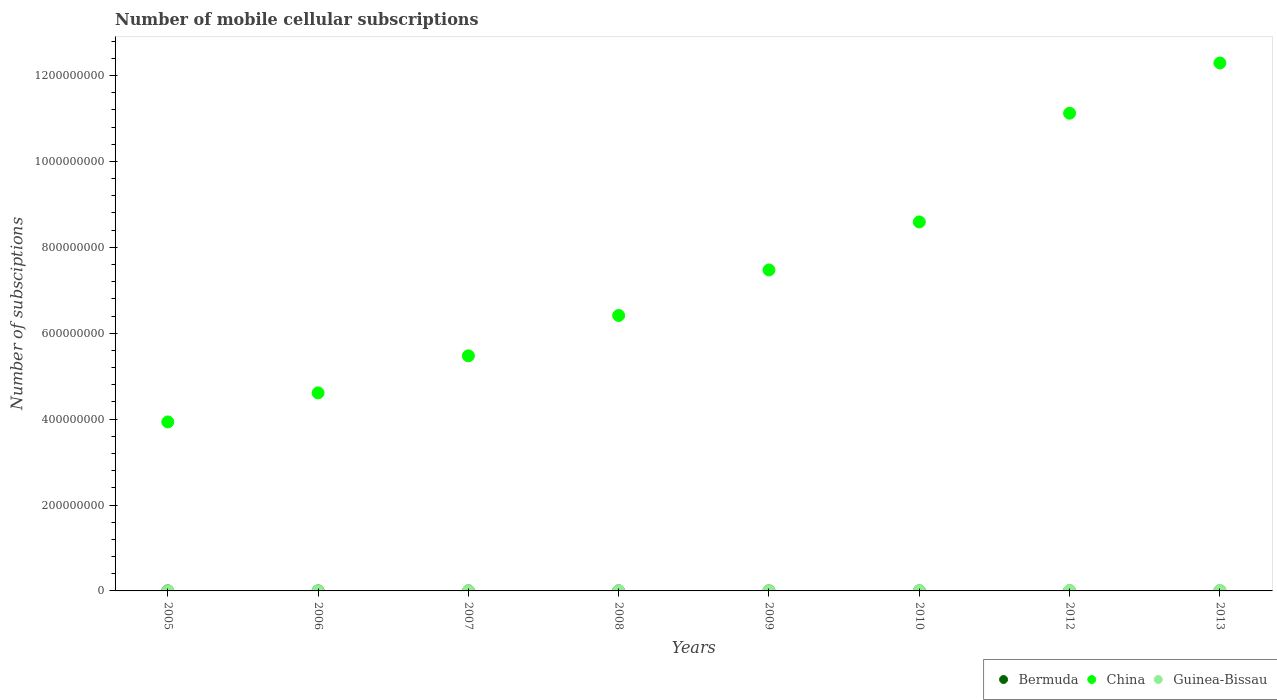What is the number of mobile cellular subscriptions in Bermuda in 2012?
Keep it short and to the point. 9.10e+04. Across all years, what is the maximum number of mobile cellular subscriptions in China?
Offer a very short reply. 1.23e+09. Across all years, what is the minimum number of mobile cellular subscriptions in Guinea-Bissau?
Your response must be concise. 9.88e+04. In which year was the number of mobile cellular subscriptions in China minimum?
Your response must be concise. 2005. What is the total number of mobile cellular subscriptions in China in the graph?
Ensure brevity in your answer.  5.99e+09. What is the difference between the number of mobile cellular subscriptions in Guinea-Bissau in 2006 and that in 2013?
Offer a terse response. -7.83e+05. What is the difference between the number of mobile cellular subscriptions in China in 2010 and the number of mobile cellular subscriptions in Guinea-Bissau in 2012?
Give a very brief answer. 8.58e+08. What is the average number of mobile cellular subscriptions in China per year?
Your answer should be very brief. 7.49e+08. In the year 2010, what is the difference between the number of mobile cellular subscriptions in Guinea-Bissau and number of mobile cellular subscriptions in China?
Offer a very short reply. -8.58e+08. In how many years, is the number of mobile cellular subscriptions in Guinea-Bissau greater than 720000000?
Your response must be concise. 0. What is the ratio of the number of mobile cellular subscriptions in Bermuda in 2005 to that in 2010?
Provide a succinct answer. 0.6. What is the difference between the highest and the second highest number of mobile cellular subscriptions in Bermuda?
Your answer should be compact. 3300. What is the difference between the highest and the lowest number of mobile cellular subscriptions in Guinea-Bissau?
Provide a succinct answer. 9.50e+05. Is the sum of the number of mobile cellular subscriptions in Bermuda in 2005 and 2006 greater than the maximum number of mobile cellular subscriptions in Guinea-Bissau across all years?
Make the answer very short. No. Does the number of mobile cellular subscriptions in Guinea-Bissau monotonically increase over the years?
Keep it short and to the point. No. What is the difference between two consecutive major ticks on the Y-axis?
Make the answer very short. 2.00e+08. Does the graph contain any zero values?
Your answer should be very brief. No. What is the title of the graph?
Your response must be concise. Number of mobile cellular subscriptions. What is the label or title of the X-axis?
Offer a terse response. Years. What is the label or title of the Y-axis?
Provide a succinct answer. Number of subsciptions. What is the Number of subsciptions in Bermuda in 2005?
Offer a terse response. 5.27e+04. What is the Number of subsciptions in China in 2005?
Provide a short and direct response. 3.93e+08. What is the Number of subsciptions in Guinea-Bissau in 2005?
Offer a very short reply. 9.88e+04. What is the Number of subsciptions in Bermuda in 2006?
Give a very brief answer. 6.01e+04. What is the Number of subsciptions in China in 2006?
Offer a terse response. 4.61e+08. What is the Number of subsciptions in Guinea-Bissau in 2006?
Your answer should be compact. 1.57e+05. What is the Number of subsciptions in Bermuda in 2007?
Provide a succinct answer. 6.90e+04. What is the Number of subsciptions of China in 2007?
Offer a terse response. 5.47e+08. What is the Number of subsciptions in Guinea-Bissau in 2007?
Offer a terse response. 2.96e+05. What is the Number of subsciptions of Bermuda in 2008?
Your response must be concise. 7.90e+04. What is the Number of subsciptions of China in 2008?
Ensure brevity in your answer.  6.41e+08. What is the Number of subsciptions of Guinea-Bissau in 2008?
Provide a succinct answer. 5.00e+05. What is the Number of subsciptions in Bermuda in 2009?
Keep it short and to the point. 8.50e+04. What is the Number of subsciptions of China in 2009?
Your response must be concise. 7.47e+08. What is the Number of subsciptions of Guinea-Bissau in 2009?
Ensure brevity in your answer.  5.60e+05. What is the Number of subsciptions of Bermuda in 2010?
Your answer should be compact. 8.82e+04. What is the Number of subsciptions of China in 2010?
Provide a succinct answer. 8.59e+08. What is the Number of subsciptions in Guinea-Bissau in 2010?
Ensure brevity in your answer.  6.77e+05. What is the Number of subsciptions of Bermuda in 2012?
Provide a succinct answer. 9.10e+04. What is the Number of subsciptions in China in 2012?
Provide a short and direct response. 1.11e+09. What is the Number of subsciptions in Guinea-Bissau in 2012?
Your answer should be very brief. 1.05e+06. What is the Number of subsciptions in Bermuda in 2013?
Make the answer very short. 9.43e+04. What is the Number of subsciptions of China in 2013?
Ensure brevity in your answer.  1.23e+09. What is the Number of subsciptions in Guinea-Bissau in 2013?
Give a very brief answer. 9.40e+05. Across all years, what is the maximum Number of subsciptions in Bermuda?
Offer a very short reply. 9.43e+04. Across all years, what is the maximum Number of subsciptions of China?
Your answer should be very brief. 1.23e+09. Across all years, what is the maximum Number of subsciptions of Guinea-Bissau?
Provide a short and direct response. 1.05e+06. Across all years, what is the minimum Number of subsciptions of Bermuda?
Provide a succinct answer. 5.27e+04. Across all years, what is the minimum Number of subsciptions in China?
Your response must be concise. 3.93e+08. Across all years, what is the minimum Number of subsciptions of Guinea-Bissau?
Your answer should be compact. 9.88e+04. What is the total Number of subsciptions of Bermuda in the graph?
Your answer should be compact. 6.19e+05. What is the total Number of subsciptions in China in the graph?
Ensure brevity in your answer.  5.99e+09. What is the total Number of subsciptions of Guinea-Bissau in the graph?
Offer a very short reply. 4.28e+06. What is the difference between the Number of subsciptions of Bermuda in 2005 and that in 2006?
Offer a terse response. -7380. What is the difference between the Number of subsciptions of China in 2005 and that in 2006?
Make the answer very short. -6.77e+07. What is the difference between the Number of subsciptions of Guinea-Bissau in 2005 and that in 2006?
Offer a terse response. -5.85e+04. What is the difference between the Number of subsciptions in Bermuda in 2005 and that in 2007?
Make the answer very short. -1.63e+04. What is the difference between the Number of subsciptions in China in 2005 and that in 2007?
Keep it short and to the point. -1.54e+08. What is the difference between the Number of subsciptions of Guinea-Bissau in 2005 and that in 2007?
Keep it short and to the point. -1.97e+05. What is the difference between the Number of subsciptions of Bermuda in 2005 and that in 2008?
Your answer should be very brief. -2.63e+04. What is the difference between the Number of subsciptions of China in 2005 and that in 2008?
Ensure brevity in your answer.  -2.48e+08. What is the difference between the Number of subsciptions of Guinea-Bissau in 2005 and that in 2008?
Provide a succinct answer. -4.01e+05. What is the difference between the Number of subsciptions in Bermuda in 2005 and that in 2009?
Your response must be concise. -3.23e+04. What is the difference between the Number of subsciptions in China in 2005 and that in 2009?
Your answer should be very brief. -3.54e+08. What is the difference between the Number of subsciptions in Guinea-Bissau in 2005 and that in 2009?
Your response must be concise. -4.62e+05. What is the difference between the Number of subsciptions of Bermuda in 2005 and that in 2010?
Offer a terse response. -3.55e+04. What is the difference between the Number of subsciptions of China in 2005 and that in 2010?
Make the answer very short. -4.66e+08. What is the difference between the Number of subsciptions in Guinea-Bissau in 2005 and that in 2010?
Ensure brevity in your answer.  -5.79e+05. What is the difference between the Number of subsciptions of Bermuda in 2005 and that in 2012?
Provide a succinct answer. -3.83e+04. What is the difference between the Number of subsciptions of China in 2005 and that in 2012?
Offer a terse response. -7.19e+08. What is the difference between the Number of subsciptions in Guinea-Bissau in 2005 and that in 2012?
Give a very brief answer. -9.50e+05. What is the difference between the Number of subsciptions of Bermuda in 2005 and that in 2013?
Your answer should be compact. -4.16e+04. What is the difference between the Number of subsciptions of China in 2005 and that in 2013?
Your answer should be very brief. -8.36e+08. What is the difference between the Number of subsciptions in Guinea-Bissau in 2005 and that in 2013?
Make the answer very short. -8.41e+05. What is the difference between the Number of subsciptions of Bermuda in 2006 and that in 2007?
Offer a very short reply. -8900. What is the difference between the Number of subsciptions of China in 2006 and that in 2007?
Offer a terse response. -8.62e+07. What is the difference between the Number of subsciptions of Guinea-Bissau in 2006 and that in 2007?
Offer a terse response. -1.39e+05. What is the difference between the Number of subsciptions in Bermuda in 2006 and that in 2008?
Provide a succinct answer. -1.89e+04. What is the difference between the Number of subsciptions in China in 2006 and that in 2008?
Your answer should be very brief. -1.80e+08. What is the difference between the Number of subsciptions in Guinea-Bissau in 2006 and that in 2008?
Ensure brevity in your answer.  -3.43e+05. What is the difference between the Number of subsciptions in Bermuda in 2006 and that in 2009?
Give a very brief answer. -2.49e+04. What is the difference between the Number of subsciptions of China in 2006 and that in 2009?
Your answer should be very brief. -2.86e+08. What is the difference between the Number of subsciptions of Guinea-Bissau in 2006 and that in 2009?
Provide a succinct answer. -4.03e+05. What is the difference between the Number of subsciptions of Bermuda in 2006 and that in 2010?
Make the answer very short. -2.81e+04. What is the difference between the Number of subsciptions of China in 2006 and that in 2010?
Your answer should be compact. -3.98e+08. What is the difference between the Number of subsciptions in Guinea-Bissau in 2006 and that in 2010?
Offer a very short reply. -5.20e+05. What is the difference between the Number of subsciptions of Bermuda in 2006 and that in 2012?
Ensure brevity in your answer.  -3.09e+04. What is the difference between the Number of subsciptions in China in 2006 and that in 2012?
Make the answer very short. -6.51e+08. What is the difference between the Number of subsciptions in Guinea-Bissau in 2006 and that in 2012?
Offer a terse response. -8.92e+05. What is the difference between the Number of subsciptions of Bermuda in 2006 and that in 2013?
Your response must be concise. -3.42e+04. What is the difference between the Number of subsciptions in China in 2006 and that in 2013?
Ensure brevity in your answer.  -7.68e+08. What is the difference between the Number of subsciptions in Guinea-Bissau in 2006 and that in 2013?
Your answer should be very brief. -7.83e+05. What is the difference between the Number of subsciptions of Bermuda in 2007 and that in 2008?
Ensure brevity in your answer.  -10000. What is the difference between the Number of subsciptions of China in 2007 and that in 2008?
Your answer should be very brief. -9.39e+07. What is the difference between the Number of subsciptions of Guinea-Bissau in 2007 and that in 2008?
Your answer should be compact. -2.04e+05. What is the difference between the Number of subsciptions of Bermuda in 2007 and that in 2009?
Make the answer very short. -1.60e+04. What is the difference between the Number of subsciptions of China in 2007 and that in 2009?
Offer a terse response. -2.00e+08. What is the difference between the Number of subsciptions in Guinea-Bissau in 2007 and that in 2009?
Your response must be concise. -2.64e+05. What is the difference between the Number of subsciptions in Bermuda in 2007 and that in 2010?
Offer a terse response. -1.92e+04. What is the difference between the Number of subsciptions in China in 2007 and that in 2010?
Offer a terse response. -3.12e+08. What is the difference between the Number of subsciptions in Guinea-Bissau in 2007 and that in 2010?
Your answer should be very brief. -3.81e+05. What is the difference between the Number of subsciptions of Bermuda in 2007 and that in 2012?
Offer a very short reply. -2.20e+04. What is the difference between the Number of subsciptions of China in 2007 and that in 2012?
Offer a terse response. -5.65e+08. What is the difference between the Number of subsciptions of Guinea-Bissau in 2007 and that in 2012?
Provide a succinct answer. -7.53e+05. What is the difference between the Number of subsciptions of Bermuda in 2007 and that in 2013?
Provide a succinct answer. -2.53e+04. What is the difference between the Number of subsciptions of China in 2007 and that in 2013?
Keep it short and to the point. -6.82e+08. What is the difference between the Number of subsciptions in Guinea-Bissau in 2007 and that in 2013?
Ensure brevity in your answer.  -6.44e+05. What is the difference between the Number of subsciptions in Bermuda in 2008 and that in 2009?
Ensure brevity in your answer.  -6000. What is the difference between the Number of subsciptions in China in 2008 and that in 2009?
Ensure brevity in your answer.  -1.06e+08. What is the difference between the Number of subsciptions in Guinea-Bissau in 2008 and that in 2009?
Your answer should be compact. -6.02e+04. What is the difference between the Number of subsciptions in Bermuda in 2008 and that in 2010?
Your response must be concise. -9200. What is the difference between the Number of subsciptions of China in 2008 and that in 2010?
Your response must be concise. -2.18e+08. What is the difference between the Number of subsciptions in Guinea-Bissau in 2008 and that in 2010?
Ensure brevity in your answer.  -1.77e+05. What is the difference between the Number of subsciptions of Bermuda in 2008 and that in 2012?
Provide a short and direct response. -1.20e+04. What is the difference between the Number of subsciptions in China in 2008 and that in 2012?
Give a very brief answer. -4.71e+08. What is the difference between the Number of subsciptions in Guinea-Bissau in 2008 and that in 2012?
Your answer should be very brief. -5.49e+05. What is the difference between the Number of subsciptions of Bermuda in 2008 and that in 2013?
Offer a very short reply. -1.53e+04. What is the difference between the Number of subsciptions in China in 2008 and that in 2013?
Your response must be concise. -5.88e+08. What is the difference between the Number of subsciptions of Guinea-Bissau in 2008 and that in 2013?
Make the answer very short. -4.40e+05. What is the difference between the Number of subsciptions of Bermuda in 2009 and that in 2010?
Give a very brief answer. -3200. What is the difference between the Number of subsciptions in China in 2009 and that in 2010?
Your response must be concise. -1.12e+08. What is the difference between the Number of subsciptions in Guinea-Bissau in 2009 and that in 2010?
Your answer should be compact. -1.17e+05. What is the difference between the Number of subsciptions in Bermuda in 2009 and that in 2012?
Your answer should be compact. -6000. What is the difference between the Number of subsciptions of China in 2009 and that in 2012?
Your answer should be compact. -3.65e+08. What is the difference between the Number of subsciptions of Guinea-Bissau in 2009 and that in 2012?
Your answer should be compact. -4.89e+05. What is the difference between the Number of subsciptions of Bermuda in 2009 and that in 2013?
Provide a short and direct response. -9300. What is the difference between the Number of subsciptions of China in 2009 and that in 2013?
Provide a succinct answer. -4.82e+08. What is the difference between the Number of subsciptions of Guinea-Bissau in 2009 and that in 2013?
Keep it short and to the point. -3.80e+05. What is the difference between the Number of subsciptions in Bermuda in 2010 and that in 2012?
Ensure brevity in your answer.  -2800. What is the difference between the Number of subsciptions in China in 2010 and that in 2012?
Offer a terse response. -2.53e+08. What is the difference between the Number of subsciptions of Guinea-Bissau in 2010 and that in 2012?
Your answer should be very brief. -3.72e+05. What is the difference between the Number of subsciptions of Bermuda in 2010 and that in 2013?
Keep it short and to the point. -6100. What is the difference between the Number of subsciptions of China in 2010 and that in 2013?
Keep it short and to the point. -3.70e+08. What is the difference between the Number of subsciptions in Guinea-Bissau in 2010 and that in 2013?
Keep it short and to the point. -2.63e+05. What is the difference between the Number of subsciptions in Bermuda in 2012 and that in 2013?
Your answer should be compact. -3300. What is the difference between the Number of subsciptions of China in 2012 and that in 2013?
Your answer should be very brief. -1.17e+08. What is the difference between the Number of subsciptions of Guinea-Bissau in 2012 and that in 2013?
Your answer should be compact. 1.09e+05. What is the difference between the Number of subsciptions of Bermuda in 2005 and the Number of subsciptions of China in 2006?
Ensure brevity in your answer.  -4.61e+08. What is the difference between the Number of subsciptions in Bermuda in 2005 and the Number of subsciptions in Guinea-Bissau in 2006?
Your answer should be compact. -1.05e+05. What is the difference between the Number of subsciptions of China in 2005 and the Number of subsciptions of Guinea-Bissau in 2006?
Offer a terse response. 3.93e+08. What is the difference between the Number of subsciptions in Bermuda in 2005 and the Number of subsciptions in China in 2007?
Provide a short and direct response. -5.47e+08. What is the difference between the Number of subsciptions in Bermuda in 2005 and the Number of subsciptions in Guinea-Bissau in 2007?
Give a very brief answer. -2.44e+05. What is the difference between the Number of subsciptions of China in 2005 and the Number of subsciptions of Guinea-Bissau in 2007?
Ensure brevity in your answer.  3.93e+08. What is the difference between the Number of subsciptions in Bermuda in 2005 and the Number of subsciptions in China in 2008?
Your response must be concise. -6.41e+08. What is the difference between the Number of subsciptions of Bermuda in 2005 and the Number of subsciptions of Guinea-Bissau in 2008?
Offer a very short reply. -4.47e+05. What is the difference between the Number of subsciptions in China in 2005 and the Number of subsciptions in Guinea-Bissau in 2008?
Provide a succinct answer. 3.93e+08. What is the difference between the Number of subsciptions in Bermuda in 2005 and the Number of subsciptions in China in 2009?
Make the answer very short. -7.47e+08. What is the difference between the Number of subsciptions of Bermuda in 2005 and the Number of subsciptions of Guinea-Bissau in 2009?
Ensure brevity in your answer.  -5.08e+05. What is the difference between the Number of subsciptions in China in 2005 and the Number of subsciptions in Guinea-Bissau in 2009?
Give a very brief answer. 3.93e+08. What is the difference between the Number of subsciptions in Bermuda in 2005 and the Number of subsciptions in China in 2010?
Your answer should be compact. -8.59e+08. What is the difference between the Number of subsciptions in Bermuda in 2005 and the Number of subsciptions in Guinea-Bissau in 2010?
Give a very brief answer. -6.25e+05. What is the difference between the Number of subsciptions of China in 2005 and the Number of subsciptions of Guinea-Bissau in 2010?
Offer a terse response. 3.93e+08. What is the difference between the Number of subsciptions of Bermuda in 2005 and the Number of subsciptions of China in 2012?
Offer a terse response. -1.11e+09. What is the difference between the Number of subsciptions in Bermuda in 2005 and the Number of subsciptions in Guinea-Bissau in 2012?
Your response must be concise. -9.96e+05. What is the difference between the Number of subsciptions of China in 2005 and the Number of subsciptions of Guinea-Bissau in 2012?
Your answer should be very brief. 3.92e+08. What is the difference between the Number of subsciptions in Bermuda in 2005 and the Number of subsciptions in China in 2013?
Your response must be concise. -1.23e+09. What is the difference between the Number of subsciptions in Bermuda in 2005 and the Number of subsciptions in Guinea-Bissau in 2013?
Your answer should be very brief. -8.87e+05. What is the difference between the Number of subsciptions of China in 2005 and the Number of subsciptions of Guinea-Bissau in 2013?
Make the answer very short. 3.92e+08. What is the difference between the Number of subsciptions of Bermuda in 2006 and the Number of subsciptions of China in 2007?
Your answer should be compact. -5.47e+08. What is the difference between the Number of subsciptions in Bermuda in 2006 and the Number of subsciptions in Guinea-Bissau in 2007?
Your response must be concise. -2.36e+05. What is the difference between the Number of subsciptions of China in 2006 and the Number of subsciptions of Guinea-Bissau in 2007?
Your answer should be very brief. 4.61e+08. What is the difference between the Number of subsciptions in Bermuda in 2006 and the Number of subsciptions in China in 2008?
Keep it short and to the point. -6.41e+08. What is the difference between the Number of subsciptions of Bermuda in 2006 and the Number of subsciptions of Guinea-Bissau in 2008?
Ensure brevity in your answer.  -4.40e+05. What is the difference between the Number of subsciptions of China in 2006 and the Number of subsciptions of Guinea-Bissau in 2008?
Offer a very short reply. 4.61e+08. What is the difference between the Number of subsciptions in Bermuda in 2006 and the Number of subsciptions in China in 2009?
Your answer should be very brief. -7.47e+08. What is the difference between the Number of subsciptions in Bermuda in 2006 and the Number of subsciptions in Guinea-Bissau in 2009?
Your answer should be compact. -5.00e+05. What is the difference between the Number of subsciptions of China in 2006 and the Number of subsciptions of Guinea-Bissau in 2009?
Provide a short and direct response. 4.60e+08. What is the difference between the Number of subsciptions in Bermuda in 2006 and the Number of subsciptions in China in 2010?
Give a very brief answer. -8.59e+08. What is the difference between the Number of subsciptions of Bermuda in 2006 and the Number of subsciptions of Guinea-Bissau in 2010?
Offer a very short reply. -6.17e+05. What is the difference between the Number of subsciptions of China in 2006 and the Number of subsciptions of Guinea-Bissau in 2010?
Offer a terse response. 4.60e+08. What is the difference between the Number of subsciptions in Bermuda in 2006 and the Number of subsciptions in China in 2012?
Your response must be concise. -1.11e+09. What is the difference between the Number of subsciptions in Bermuda in 2006 and the Number of subsciptions in Guinea-Bissau in 2012?
Make the answer very short. -9.89e+05. What is the difference between the Number of subsciptions of China in 2006 and the Number of subsciptions of Guinea-Bissau in 2012?
Make the answer very short. 4.60e+08. What is the difference between the Number of subsciptions of Bermuda in 2006 and the Number of subsciptions of China in 2013?
Provide a succinct answer. -1.23e+09. What is the difference between the Number of subsciptions of Bermuda in 2006 and the Number of subsciptions of Guinea-Bissau in 2013?
Ensure brevity in your answer.  -8.80e+05. What is the difference between the Number of subsciptions in China in 2006 and the Number of subsciptions in Guinea-Bissau in 2013?
Your response must be concise. 4.60e+08. What is the difference between the Number of subsciptions in Bermuda in 2007 and the Number of subsciptions in China in 2008?
Give a very brief answer. -6.41e+08. What is the difference between the Number of subsciptions in Bermuda in 2007 and the Number of subsciptions in Guinea-Bissau in 2008?
Give a very brief answer. -4.31e+05. What is the difference between the Number of subsciptions in China in 2007 and the Number of subsciptions in Guinea-Bissau in 2008?
Provide a succinct answer. 5.47e+08. What is the difference between the Number of subsciptions of Bermuda in 2007 and the Number of subsciptions of China in 2009?
Ensure brevity in your answer.  -7.47e+08. What is the difference between the Number of subsciptions in Bermuda in 2007 and the Number of subsciptions in Guinea-Bissau in 2009?
Your response must be concise. -4.91e+05. What is the difference between the Number of subsciptions in China in 2007 and the Number of subsciptions in Guinea-Bissau in 2009?
Offer a very short reply. 5.47e+08. What is the difference between the Number of subsciptions in Bermuda in 2007 and the Number of subsciptions in China in 2010?
Offer a very short reply. -8.59e+08. What is the difference between the Number of subsciptions in Bermuda in 2007 and the Number of subsciptions in Guinea-Bissau in 2010?
Offer a very short reply. -6.08e+05. What is the difference between the Number of subsciptions of China in 2007 and the Number of subsciptions of Guinea-Bissau in 2010?
Offer a terse response. 5.47e+08. What is the difference between the Number of subsciptions in Bermuda in 2007 and the Number of subsciptions in China in 2012?
Your answer should be compact. -1.11e+09. What is the difference between the Number of subsciptions of Bermuda in 2007 and the Number of subsciptions of Guinea-Bissau in 2012?
Your answer should be very brief. -9.80e+05. What is the difference between the Number of subsciptions of China in 2007 and the Number of subsciptions of Guinea-Bissau in 2012?
Keep it short and to the point. 5.46e+08. What is the difference between the Number of subsciptions in Bermuda in 2007 and the Number of subsciptions in China in 2013?
Your answer should be compact. -1.23e+09. What is the difference between the Number of subsciptions of Bermuda in 2007 and the Number of subsciptions of Guinea-Bissau in 2013?
Offer a very short reply. -8.71e+05. What is the difference between the Number of subsciptions of China in 2007 and the Number of subsciptions of Guinea-Bissau in 2013?
Make the answer very short. 5.46e+08. What is the difference between the Number of subsciptions of Bermuda in 2008 and the Number of subsciptions of China in 2009?
Make the answer very short. -7.47e+08. What is the difference between the Number of subsciptions of Bermuda in 2008 and the Number of subsciptions of Guinea-Bissau in 2009?
Offer a terse response. -4.81e+05. What is the difference between the Number of subsciptions in China in 2008 and the Number of subsciptions in Guinea-Bissau in 2009?
Provide a succinct answer. 6.41e+08. What is the difference between the Number of subsciptions of Bermuda in 2008 and the Number of subsciptions of China in 2010?
Your answer should be very brief. -8.59e+08. What is the difference between the Number of subsciptions in Bermuda in 2008 and the Number of subsciptions in Guinea-Bissau in 2010?
Provide a short and direct response. -5.98e+05. What is the difference between the Number of subsciptions of China in 2008 and the Number of subsciptions of Guinea-Bissau in 2010?
Give a very brief answer. 6.41e+08. What is the difference between the Number of subsciptions of Bermuda in 2008 and the Number of subsciptions of China in 2012?
Offer a very short reply. -1.11e+09. What is the difference between the Number of subsciptions of Bermuda in 2008 and the Number of subsciptions of Guinea-Bissau in 2012?
Provide a succinct answer. -9.70e+05. What is the difference between the Number of subsciptions of China in 2008 and the Number of subsciptions of Guinea-Bissau in 2012?
Provide a succinct answer. 6.40e+08. What is the difference between the Number of subsciptions of Bermuda in 2008 and the Number of subsciptions of China in 2013?
Offer a very short reply. -1.23e+09. What is the difference between the Number of subsciptions of Bermuda in 2008 and the Number of subsciptions of Guinea-Bissau in 2013?
Make the answer very short. -8.61e+05. What is the difference between the Number of subsciptions in China in 2008 and the Number of subsciptions in Guinea-Bissau in 2013?
Give a very brief answer. 6.40e+08. What is the difference between the Number of subsciptions of Bermuda in 2009 and the Number of subsciptions of China in 2010?
Make the answer very short. -8.59e+08. What is the difference between the Number of subsciptions in Bermuda in 2009 and the Number of subsciptions in Guinea-Bissau in 2010?
Offer a terse response. -5.92e+05. What is the difference between the Number of subsciptions of China in 2009 and the Number of subsciptions of Guinea-Bissau in 2010?
Ensure brevity in your answer.  7.47e+08. What is the difference between the Number of subsciptions of Bermuda in 2009 and the Number of subsciptions of China in 2012?
Offer a terse response. -1.11e+09. What is the difference between the Number of subsciptions in Bermuda in 2009 and the Number of subsciptions in Guinea-Bissau in 2012?
Provide a succinct answer. -9.64e+05. What is the difference between the Number of subsciptions in China in 2009 and the Number of subsciptions in Guinea-Bissau in 2012?
Your answer should be very brief. 7.46e+08. What is the difference between the Number of subsciptions in Bermuda in 2009 and the Number of subsciptions in China in 2013?
Provide a succinct answer. -1.23e+09. What is the difference between the Number of subsciptions in Bermuda in 2009 and the Number of subsciptions in Guinea-Bissau in 2013?
Your answer should be very brief. -8.55e+05. What is the difference between the Number of subsciptions of China in 2009 and the Number of subsciptions of Guinea-Bissau in 2013?
Offer a terse response. 7.46e+08. What is the difference between the Number of subsciptions in Bermuda in 2010 and the Number of subsciptions in China in 2012?
Ensure brevity in your answer.  -1.11e+09. What is the difference between the Number of subsciptions in Bermuda in 2010 and the Number of subsciptions in Guinea-Bissau in 2012?
Provide a succinct answer. -9.61e+05. What is the difference between the Number of subsciptions in China in 2010 and the Number of subsciptions in Guinea-Bissau in 2012?
Your answer should be compact. 8.58e+08. What is the difference between the Number of subsciptions in Bermuda in 2010 and the Number of subsciptions in China in 2013?
Your response must be concise. -1.23e+09. What is the difference between the Number of subsciptions in Bermuda in 2010 and the Number of subsciptions in Guinea-Bissau in 2013?
Your response must be concise. -8.52e+05. What is the difference between the Number of subsciptions in China in 2010 and the Number of subsciptions in Guinea-Bissau in 2013?
Offer a very short reply. 8.58e+08. What is the difference between the Number of subsciptions in Bermuda in 2012 and the Number of subsciptions in China in 2013?
Offer a very short reply. -1.23e+09. What is the difference between the Number of subsciptions in Bermuda in 2012 and the Number of subsciptions in Guinea-Bissau in 2013?
Make the answer very short. -8.49e+05. What is the difference between the Number of subsciptions in China in 2012 and the Number of subsciptions in Guinea-Bissau in 2013?
Provide a short and direct response. 1.11e+09. What is the average Number of subsciptions in Bermuda per year?
Ensure brevity in your answer.  7.74e+04. What is the average Number of subsciptions of China per year?
Your answer should be compact. 7.49e+08. What is the average Number of subsciptions in Guinea-Bissau per year?
Your answer should be very brief. 5.35e+05. In the year 2005, what is the difference between the Number of subsciptions of Bermuda and Number of subsciptions of China?
Provide a succinct answer. -3.93e+08. In the year 2005, what is the difference between the Number of subsciptions in Bermuda and Number of subsciptions in Guinea-Bissau?
Offer a very short reply. -4.61e+04. In the year 2005, what is the difference between the Number of subsciptions of China and Number of subsciptions of Guinea-Bissau?
Make the answer very short. 3.93e+08. In the year 2006, what is the difference between the Number of subsciptions of Bermuda and Number of subsciptions of China?
Ensure brevity in your answer.  -4.61e+08. In the year 2006, what is the difference between the Number of subsciptions of Bermuda and Number of subsciptions of Guinea-Bissau?
Make the answer very short. -9.72e+04. In the year 2006, what is the difference between the Number of subsciptions in China and Number of subsciptions in Guinea-Bissau?
Offer a very short reply. 4.61e+08. In the year 2007, what is the difference between the Number of subsciptions in Bermuda and Number of subsciptions in China?
Offer a very short reply. -5.47e+08. In the year 2007, what is the difference between the Number of subsciptions in Bermuda and Number of subsciptions in Guinea-Bissau?
Make the answer very short. -2.27e+05. In the year 2007, what is the difference between the Number of subsciptions in China and Number of subsciptions in Guinea-Bissau?
Ensure brevity in your answer.  5.47e+08. In the year 2008, what is the difference between the Number of subsciptions in Bermuda and Number of subsciptions in China?
Your answer should be compact. -6.41e+08. In the year 2008, what is the difference between the Number of subsciptions in Bermuda and Number of subsciptions in Guinea-Bissau?
Provide a succinct answer. -4.21e+05. In the year 2008, what is the difference between the Number of subsciptions of China and Number of subsciptions of Guinea-Bissau?
Make the answer very short. 6.41e+08. In the year 2009, what is the difference between the Number of subsciptions in Bermuda and Number of subsciptions in China?
Ensure brevity in your answer.  -7.47e+08. In the year 2009, what is the difference between the Number of subsciptions of Bermuda and Number of subsciptions of Guinea-Bissau?
Offer a terse response. -4.75e+05. In the year 2009, what is the difference between the Number of subsciptions in China and Number of subsciptions in Guinea-Bissau?
Ensure brevity in your answer.  7.47e+08. In the year 2010, what is the difference between the Number of subsciptions in Bermuda and Number of subsciptions in China?
Give a very brief answer. -8.59e+08. In the year 2010, what is the difference between the Number of subsciptions in Bermuda and Number of subsciptions in Guinea-Bissau?
Your answer should be very brief. -5.89e+05. In the year 2010, what is the difference between the Number of subsciptions in China and Number of subsciptions in Guinea-Bissau?
Ensure brevity in your answer.  8.58e+08. In the year 2012, what is the difference between the Number of subsciptions in Bermuda and Number of subsciptions in China?
Provide a short and direct response. -1.11e+09. In the year 2012, what is the difference between the Number of subsciptions of Bermuda and Number of subsciptions of Guinea-Bissau?
Keep it short and to the point. -9.58e+05. In the year 2012, what is the difference between the Number of subsciptions of China and Number of subsciptions of Guinea-Bissau?
Your answer should be compact. 1.11e+09. In the year 2013, what is the difference between the Number of subsciptions of Bermuda and Number of subsciptions of China?
Offer a terse response. -1.23e+09. In the year 2013, what is the difference between the Number of subsciptions in Bermuda and Number of subsciptions in Guinea-Bissau?
Your answer should be very brief. -8.46e+05. In the year 2013, what is the difference between the Number of subsciptions in China and Number of subsciptions in Guinea-Bissau?
Give a very brief answer. 1.23e+09. What is the ratio of the Number of subsciptions in Bermuda in 2005 to that in 2006?
Make the answer very short. 0.88. What is the ratio of the Number of subsciptions in China in 2005 to that in 2006?
Make the answer very short. 0.85. What is the ratio of the Number of subsciptions in Guinea-Bissau in 2005 to that in 2006?
Give a very brief answer. 0.63. What is the ratio of the Number of subsciptions in Bermuda in 2005 to that in 2007?
Provide a succinct answer. 0.76. What is the ratio of the Number of subsciptions in China in 2005 to that in 2007?
Keep it short and to the point. 0.72. What is the ratio of the Number of subsciptions in Guinea-Bissau in 2005 to that in 2007?
Your answer should be very brief. 0.33. What is the ratio of the Number of subsciptions in Bermuda in 2005 to that in 2008?
Offer a terse response. 0.67. What is the ratio of the Number of subsciptions of China in 2005 to that in 2008?
Provide a succinct answer. 0.61. What is the ratio of the Number of subsciptions of Guinea-Bissau in 2005 to that in 2008?
Offer a terse response. 0.2. What is the ratio of the Number of subsciptions in Bermuda in 2005 to that in 2009?
Ensure brevity in your answer.  0.62. What is the ratio of the Number of subsciptions of China in 2005 to that in 2009?
Offer a very short reply. 0.53. What is the ratio of the Number of subsciptions in Guinea-Bissau in 2005 to that in 2009?
Provide a succinct answer. 0.18. What is the ratio of the Number of subsciptions in Bermuda in 2005 to that in 2010?
Keep it short and to the point. 0.6. What is the ratio of the Number of subsciptions of China in 2005 to that in 2010?
Provide a short and direct response. 0.46. What is the ratio of the Number of subsciptions of Guinea-Bissau in 2005 to that in 2010?
Your response must be concise. 0.15. What is the ratio of the Number of subsciptions in Bermuda in 2005 to that in 2012?
Provide a short and direct response. 0.58. What is the ratio of the Number of subsciptions in China in 2005 to that in 2012?
Provide a short and direct response. 0.35. What is the ratio of the Number of subsciptions in Guinea-Bissau in 2005 to that in 2012?
Provide a succinct answer. 0.09. What is the ratio of the Number of subsciptions in Bermuda in 2005 to that in 2013?
Provide a short and direct response. 0.56. What is the ratio of the Number of subsciptions in China in 2005 to that in 2013?
Give a very brief answer. 0.32. What is the ratio of the Number of subsciptions in Guinea-Bissau in 2005 to that in 2013?
Your answer should be compact. 0.11. What is the ratio of the Number of subsciptions of Bermuda in 2006 to that in 2007?
Your answer should be very brief. 0.87. What is the ratio of the Number of subsciptions in China in 2006 to that in 2007?
Your answer should be very brief. 0.84. What is the ratio of the Number of subsciptions of Guinea-Bissau in 2006 to that in 2007?
Give a very brief answer. 0.53. What is the ratio of the Number of subsciptions in Bermuda in 2006 to that in 2008?
Make the answer very short. 0.76. What is the ratio of the Number of subsciptions in China in 2006 to that in 2008?
Give a very brief answer. 0.72. What is the ratio of the Number of subsciptions in Guinea-Bissau in 2006 to that in 2008?
Provide a succinct answer. 0.31. What is the ratio of the Number of subsciptions of Bermuda in 2006 to that in 2009?
Provide a short and direct response. 0.71. What is the ratio of the Number of subsciptions in China in 2006 to that in 2009?
Keep it short and to the point. 0.62. What is the ratio of the Number of subsciptions in Guinea-Bissau in 2006 to that in 2009?
Ensure brevity in your answer.  0.28. What is the ratio of the Number of subsciptions in Bermuda in 2006 to that in 2010?
Your response must be concise. 0.68. What is the ratio of the Number of subsciptions in China in 2006 to that in 2010?
Ensure brevity in your answer.  0.54. What is the ratio of the Number of subsciptions in Guinea-Bissau in 2006 to that in 2010?
Your answer should be very brief. 0.23. What is the ratio of the Number of subsciptions of Bermuda in 2006 to that in 2012?
Keep it short and to the point. 0.66. What is the ratio of the Number of subsciptions of China in 2006 to that in 2012?
Ensure brevity in your answer.  0.41. What is the ratio of the Number of subsciptions of Bermuda in 2006 to that in 2013?
Offer a terse response. 0.64. What is the ratio of the Number of subsciptions of China in 2006 to that in 2013?
Offer a very short reply. 0.38. What is the ratio of the Number of subsciptions of Guinea-Bissau in 2006 to that in 2013?
Provide a short and direct response. 0.17. What is the ratio of the Number of subsciptions in Bermuda in 2007 to that in 2008?
Offer a very short reply. 0.87. What is the ratio of the Number of subsciptions in China in 2007 to that in 2008?
Provide a succinct answer. 0.85. What is the ratio of the Number of subsciptions of Guinea-Bissau in 2007 to that in 2008?
Offer a terse response. 0.59. What is the ratio of the Number of subsciptions in Bermuda in 2007 to that in 2009?
Your response must be concise. 0.81. What is the ratio of the Number of subsciptions of China in 2007 to that in 2009?
Keep it short and to the point. 0.73. What is the ratio of the Number of subsciptions in Guinea-Bissau in 2007 to that in 2009?
Ensure brevity in your answer.  0.53. What is the ratio of the Number of subsciptions in Bermuda in 2007 to that in 2010?
Your answer should be very brief. 0.78. What is the ratio of the Number of subsciptions in China in 2007 to that in 2010?
Make the answer very short. 0.64. What is the ratio of the Number of subsciptions in Guinea-Bissau in 2007 to that in 2010?
Provide a succinct answer. 0.44. What is the ratio of the Number of subsciptions of Bermuda in 2007 to that in 2012?
Keep it short and to the point. 0.76. What is the ratio of the Number of subsciptions in China in 2007 to that in 2012?
Give a very brief answer. 0.49. What is the ratio of the Number of subsciptions of Guinea-Bissau in 2007 to that in 2012?
Ensure brevity in your answer.  0.28. What is the ratio of the Number of subsciptions in Bermuda in 2007 to that in 2013?
Provide a succinct answer. 0.73. What is the ratio of the Number of subsciptions in China in 2007 to that in 2013?
Ensure brevity in your answer.  0.45. What is the ratio of the Number of subsciptions in Guinea-Bissau in 2007 to that in 2013?
Ensure brevity in your answer.  0.32. What is the ratio of the Number of subsciptions of Bermuda in 2008 to that in 2009?
Ensure brevity in your answer.  0.93. What is the ratio of the Number of subsciptions of China in 2008 to that in 2009?
Ensure brevity in your answer.  0.86. What is the ratio of the Number of subsciptions of Guinea-Bissau in 2008 to that in 2009?
Your response must be concise. 0.89. What is the ratio of the Number of subsciptions of Bermuda in 2008 to that in 2010?
Provide a short and direct response. 0.9. What is the ratio of the Number of subsciptions in China in 2008 to that in 2010?
Make the answer very short. 0.75. What is the ratio of the Number of subsciptions of Guinea-Bissau in 2008 to that in 2010?
Give a very brief answer. 0.74. What is the ratio of the Number of subsciptions in Bermuda in 2008 to that in 2012?
Offer a very short reply. 0.87. What is the ratio of the Number of subsciptions in China in 2008 to that in 2012?
Your answer should be very brief. 0.58. What is the ratio of the Number of subsciptions of Guinea-Bissau in 2008 to that in 2012?
Offer a terse response. 0.48. What is the ratio of the Number of subsciptions of Bermuda in 2008 to that in 2013?
Provide a succinct answer. 0.84. What is the ratio of the Number of subsciptions in China in 2008 to that in 2013?
Ensure brevity in your answer.  0.52. What is the ratio of the Number of subsciptions in Guinea-Bissau in 2008 to that in 2013?
Your answer should be compact. 0.53. What is the ratio of the Number of subsciptions of Bermuda in 2009 to that in 2010?
Offer a terse response. 0.96. What is the ratio of the Number of subsciptions of China in 2009 to that in 2010?
Offer a very short reply. 0.87. What is the ratio of the Number of subsciptions of Guinea-Bissau in 2009 to that in 2010?
Ensure brevity in your answer.  0.83. What is the ratio of the Number of subsciptions in Bermuda in 2009 to that in 2012?
Provide a short and direct response. 0.93. What is the ratio of the Number of subsciptions of China in 2009 to that in 2012?
Offer a very short reply. 0.67. What is the ratio of the Number of subsciptions in Guinea-Bissau in 2009 to that in 2012?
Your answer should be compact. 0.53. What is the ratio of the Number of subsciptions of Bermuda in 2009 to that in 2013?
Make the answer very short. 0.9. What is the ratio of the Number of subsciptions of China in 2009 to that in 2013?
Provide a succinct answer. 0.61. What is the ratio of the Number of subsciptions in Guinea-Bissau in 2009 to that in 2013?
Give a very brief answer. 0.6. What is the ratio of the Number of subsciptions in Bermuda in 2010 to that in 2012?
Your answer should be very brief. 0.97. What is the ratio of the Number of subsciptions in China in 2010 to that in 2012?
Your answer should be compact. 0.77. What is the ratio of the Number of subsciptions of Guinea-Bissau in 2010 to that in 2012?
Ensure brevity in your answer.  0.65. What is the ratio of the Number of subsciptions in Bermuda in 2010 to that in 2013?
Provide a short and direct response. 0.94. What is the ratio of the Number of subsciptions of China in 2010 to that in 2013?
Make the answer very short. 0.7. What is the ratio of the Number of subsciptions in Guinea-Bissau in 2010 to that in 2013?
Offer a terse response. 0.72. What is the ratio of the Number of subsciptions in Bermuda in 2012 to that in 2013?
Give a very brief answer. 0.96. What is the ratio of the Number of subsciptions in China in 2012 to that in 2013?
Provide a short and direct response. 0.9. What is the ratio of the Number of subsciptions in Guinea-Bissau in 2012 to that in 2013?
Provide a short and direct response. 1.12. What is the difference between the highest and the second highest Number of subsciptions of Bermuda?
Your answer should be very brief. 3300. What is the difference between the highest and the second highest Number of subsciptions of China?
Offer a terse response. 1.17e+08. What is the difference between the highest and the second highest Number of subsciptions of Guinea-Bissau?
Offer a terse response. 1.09e+05. What is the difference between the highest and the lowest Number of subsciptions of Bermuda?
Make the answer very short. 4.16e+04. What is the difference between the highest and the lowest Number of subsciptions of China?
Ensure brevity in your answer.  8.36e+08. What is the difference between the highest and the lowest Number of subsciptions in Guinea-Bissau?
Your answer should be compact. 9.50e+05. 